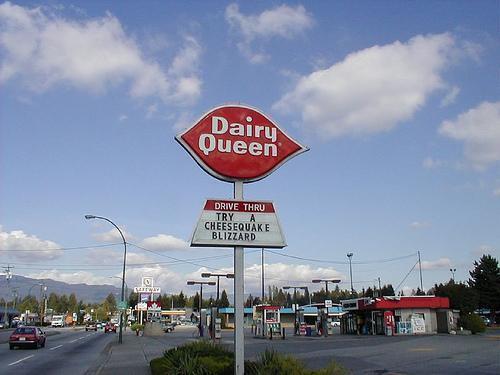How many bears are wearing a cap?
Give a very brief answer. 0. 